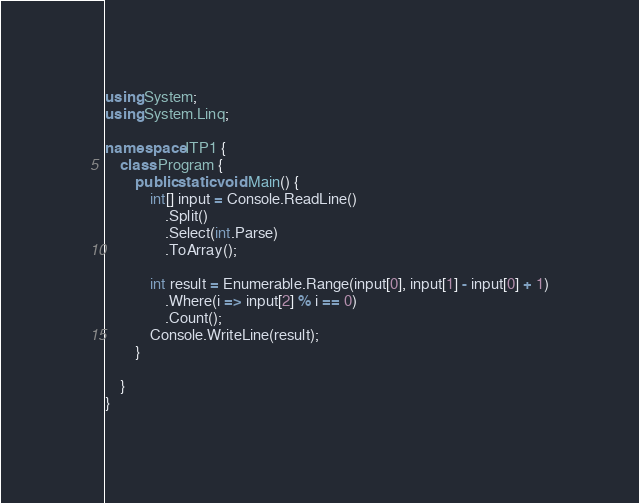Convert code to text. <code><loc_0><loc_0><loc_500><loc_500><_C#_>using System;
using System.Linq;

namespace ITP1 {
	class Program {
		public static void Main() {
			int[] input = Console.ReadLine()
				.Split()
				.Select(int.Parse)
				.ToArray();

			int result = Enumerable.Range(input[0], input[1] - input[0] + 1)
				.Where(i => input[2] % i == 0)
				.Count();
			Console.WriteLine(result);
		}

	}
}

</code> 